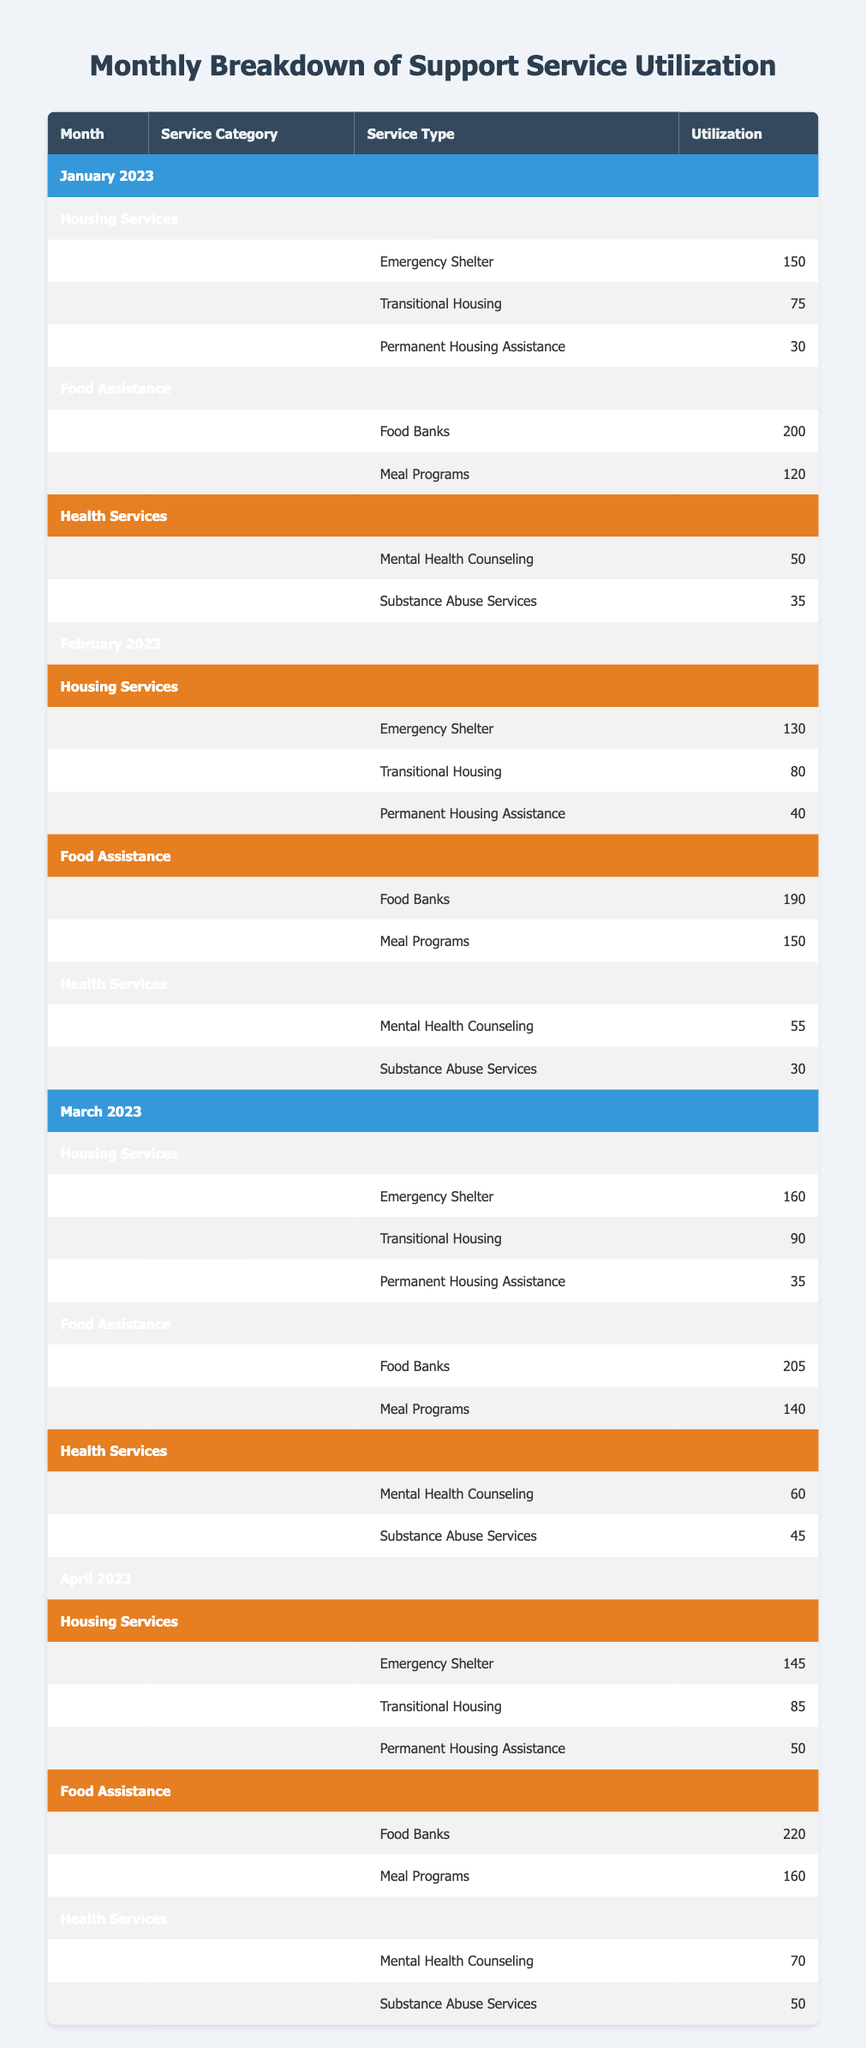What was the total utilization of Emergency Shelter services in February 2023? The data shows that in February 2023, the utilization of Emergency Shelter was 130.
Answer: 130 Which type of Food Assistance had the highest utilization in April 2023? In April 2023, the Food Assistance types were Food Banks with 220 utilizations and Meal Programs with 160. The highest is Food Banks with 220.
Answer: Food Banks What is the average number of Mental Health Counseling utilizations over the four months? The utilizations for Mental Health Counseling are 50, 55, 60, and 70 in January, February, March, and April respectively. Summing these gives 50 + 55 + 60 + 70 = 235. Then, dividing by 4 gives an average of 235/4 = 58.75.
Answer: 58.75 Did the total utilization of transitional housing increase, decrease, or remain the same from January to April 2023? In January, transitional housing utilization was 75. In February, it increased to 80. In March, it further increased to 90, and in April, it decreased to 85. The trend shows an increase from January to March and a decrease in April, indicating it fluctuated but ultimately increased by 10 from January (75) to April (85).
Answer: Increased What was the difference in the total utilization between Permanent Housing Assistance in January and April 2023? The utilization for Permanent Housing Assistance in January was 30, and in April it was 50. To find the difference, we subtract 30 from 50, resulting in 50 - 30 = 20.
Answer: 20 Which month had the lowest overall utilization for Health Services? The Health Services utilizations per month are: January (50 + 35 = 85), February (55 + 30 = 85), March (60 + 45 = 105), and April (70 + 50 = 120). January and February both had 85; therefore, they both had the lowest overall utilization for Health Services.
Answer: January and February What was the total utilization of Food Banks across all four months? The utilizations for Food Banks in January, February, March, and April are 200, 190, 205, and 220 respectively. Summing these gives 200 + 190 + 205 + 220 = 815.
Answer: 815 Which service category had the highest utilization in March 2023? To determine the highest service category in March, we find the total for each category: Housing Services (160 + 90 + 35 = 285), Food Assistance (205 + 140 = 345), and Health Services (60 + 45 = 105). The highest is Food Assistance with 345.
Answer: Food Assistance 